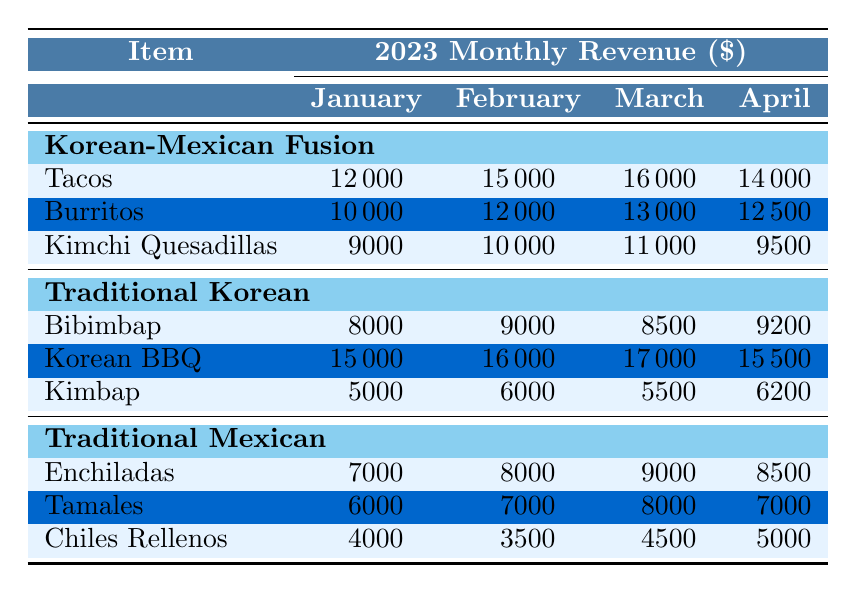What's the total revenue for Korean-Mexican Fusion in March? To find the total revenue for Korean-Mexican Fusion in March, we sum the revenues from Tacos, Burritos, and Kimchi Quesadillas. The values are 16000 (Tacos) + 13000 (Burritos) + 11000 (Kimchi Quesadillas) = 40000.
Answer: 40000 Which cuisine type had the highest revenue from Korean BBQ across the four months? From the table, the revenues for Korean BBQ are as follows: January 15000, February 16000, March 17000, April 15500. The highest revenue was in March at 17000.
Answer: March Did Traditional Mexican cuisine generate more than 30000 in total revenue during January? For Traditional Mexican in January, the revenues are: Enchiladas 7000 + Tamales 6000 + Chiles Rellenos 4000 = 17000. Since 17000 is less than 30000, the answer is no.
Answer: No What was the change in revenue from Tacos in February compared to January? For Tacos, the revenue in February is 15000 and in January it is 12000. The change can be calculated as 15000 - 12000 = 3000.
Answer: 3000 What is the average revenue for all Traditional Korean dishes in April? The revenues for Traditional Korean dishes in April are: Bibimbap 9200, Korean BBQ 15500, Kimbap 6200. First we sum them: 9200 + 15500 + 6200 = 30900. Since there are 3 dishes, we divide 30900 by 3, giving us an average of 10300.
Answer: 10300 Which dish in Korean-Mexican Fusion had the lowest revenue in January? In January, the revenues for the dishes are: Tacos 12000, Burritos 10000, Kimchi Quesadillas 9000. The lowest revenue is from Kimchi Quesadillas at 9000.
Answer: Kimchi Quesadillas How much more revenue did Burritos generate in March compared to April? Burritos generated 13000 in March and 12500 in April. The difference is 13000 - 12500 = 500.
Answer: 500 Was the total revenue for Traditional Korean dishes higher than 60000 across all four months? We sum the revenues for each month: January 8000 + 15000 + 5000 = 28000 February 9000 + 16000 + 6000 = 31000 March 8500 + 17000 + 5500 = 30000 April 9200 + 15500 + 6200 = 30900. The total is 28000 + 31000 + 30000 + 30900 = 119900, which is higher than 60000.
Answer: Yes 